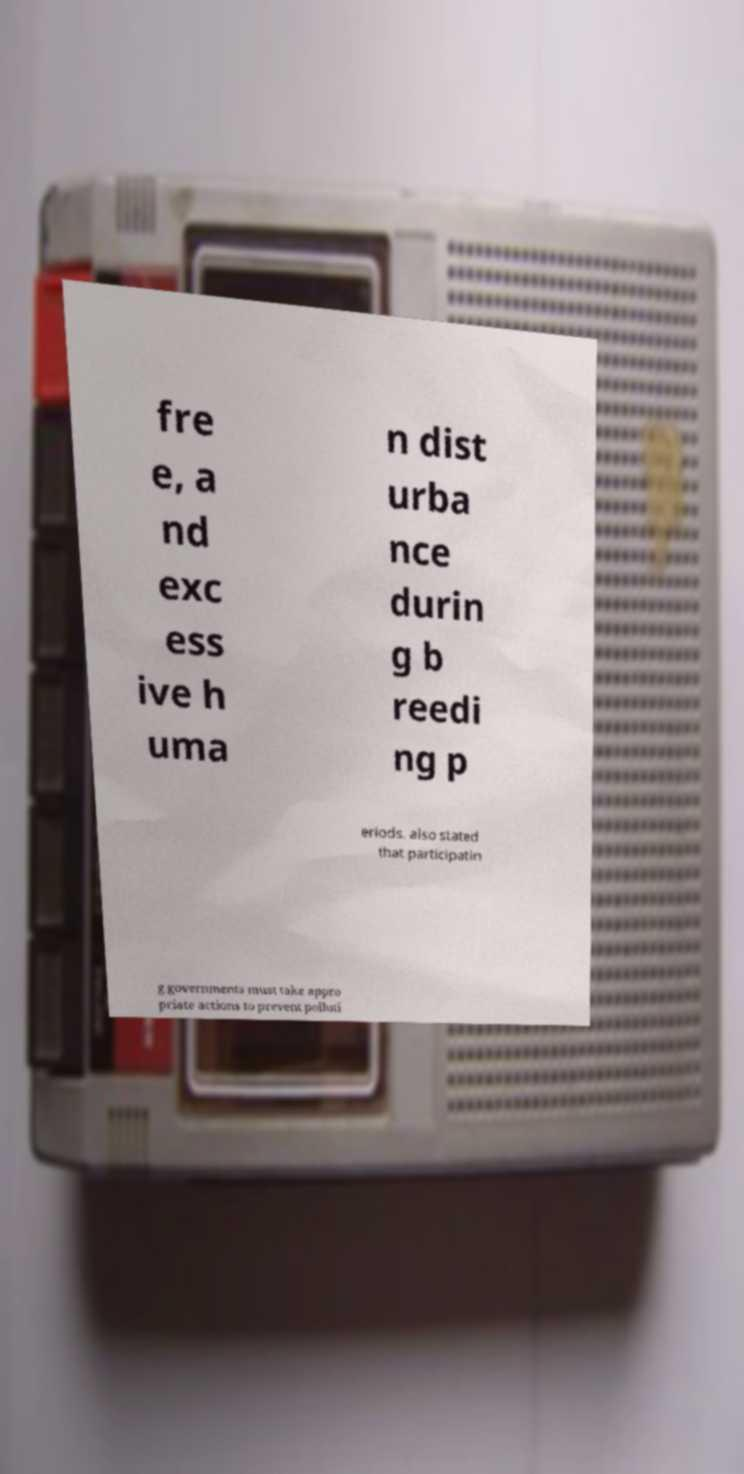What messages or text are displayed in this image? I need them in a readable, typed format. fre e, a nd exc ess ive h uma n dist urba nce durin g b reedi ng p eriods. also stated that participatin g governments must take appro priate actions to prevent polluti 